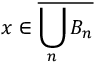<formula> <loc_0><loc_0><loc_500><loc_500>x \in { \overline { { \bigcup _ { n } B _ { n } } } }</formula> 